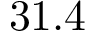Convert formula to latex. <formula><loc_0><loc_0><loc_500><loc_500>3 1 . 4</formula> 